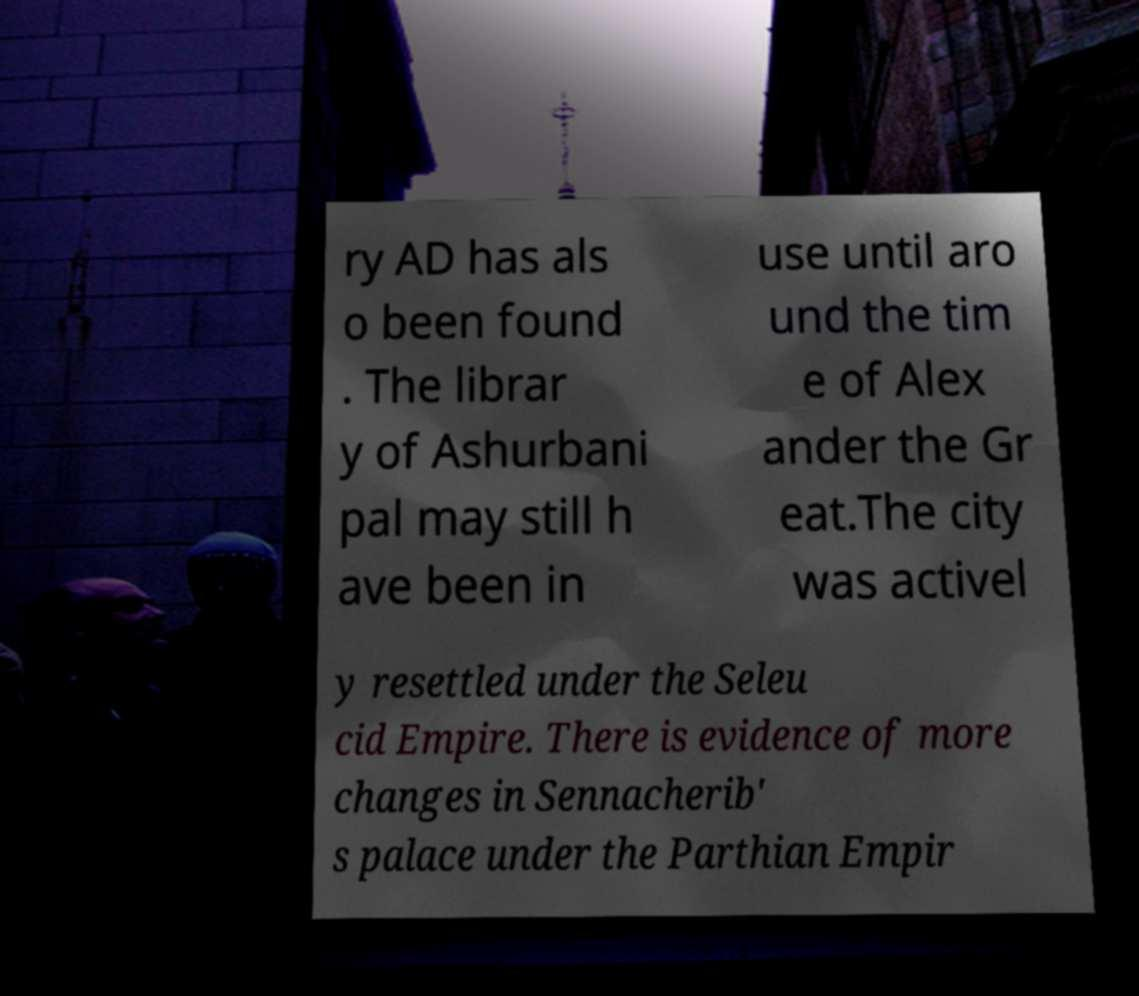Could you extract and type out the text from this image? ry AD has als o been found . The librar y of Ashurbani pal may still h ave been in use until aro und the tim e of Alex ander the Gr eat.The city was activel y resettled under the Seleu cid Empire. There is evidence of more changes in Sennacherib' s palace under the Parthian Empir 